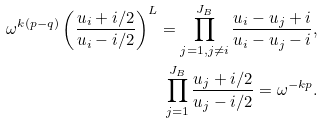<formula> <loc_0><loc_0><loc_500><loc_500>\omega ^ { k ( p - q ) } \left ( \frac { u _ { i } + i / 2 } { u _ { i } - i / 2 } \right ) ^ { L } = \prod _ { j = 1 , j \neq i } ^ { J _ { B } } \frac { u _ { i } - u _ { j } + i } { u _ { i } - u _ { j } - i } , \\ \prod _ { j = 1 } ^ { J _ { B } } \frac { u _ { j } + i / 2 } { u _ { j } - i / 2 } = \omega ^ { - k p } .</formula> 